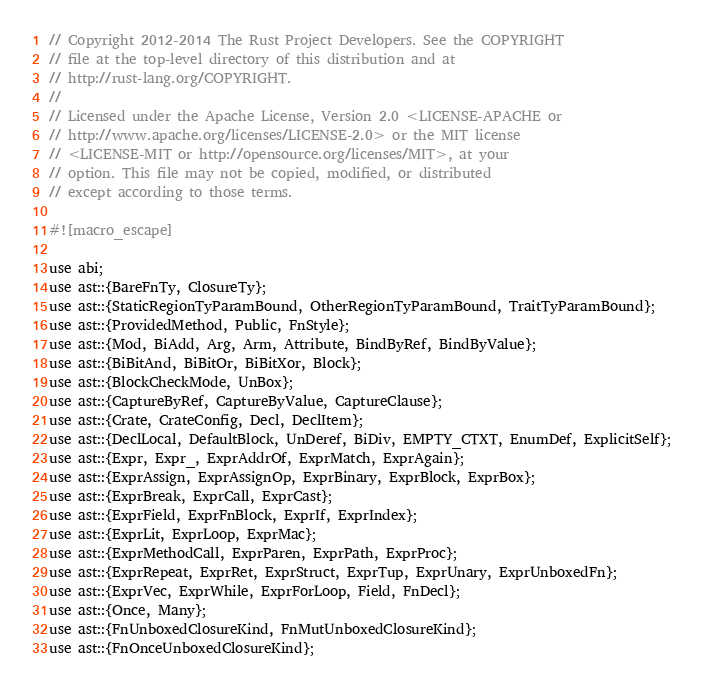<code> <loc_0><loc_0><loc_500><loc_500><_Rust_>// Copyright 2012-2014 The Rust Project Developers. See the COPYRIGHT
// file at the top-level directory of this distribution and at
// http://rust-lang.org/COPYRIGHT.
//
// Licensed under the Apache License, Version 2.0 <LICENSE-APACHE or
// http://www.apache.org/licenses/LICENSE-2.0> or the MIT license
// <LICENSE-MIT or http://opensource.org/licenses/MIT>, at your
// option. This file may not be copied, modified, or distributed
// except according to those terms.

#![macro_escape]

use abi;
use ast::{BareFnTy, ClosureTy};
use ast::{StaticRegionTyParamBound, OtherRegionTyParamBound, TraitTyParamBound};
use ast::{ProvidedMethod, Public, FnStyle};
use ast::{Mod, BiAdd, Arg, Arm, Attribute, BindByRef, BindByValue};
use ast::{BiBitAnd, BiBitOr, BiBitXor, Block};
use ast::{BlockCheckMode, UnBox};
use ast::{CaptureByRef, CaptureByValue, CaptureClause};
use ast::{Crate, CrateConfig, Decl, DeclItem};
use ast::{DeclLocal, DefaultBlock, UnDeref, BiDiv, EMPTY_CTXT, EnumDef, ExplicitSelf};
use ast::{Expr, Expr_, ExprAddrOf, ExprMatch, ExprAgain};
use ast::{ExprAssign, ExprAssignOp, ExprBinary, ExprBlock, ExprBox};
use ast::{ExprBreak, ExprCall, ExprCast};
use ast::{ExprField, ExprFnBlock, ExprIf, ExprIndex};
use ast::{ExprLit, ExprLoop, ExprMac};
use ast::{ExprMethodCall, ExprParen, ExprPath, ExprProc};
use ast::{ExprRepeat, ExprRet, ExprStruct, ExprTup, ExprUnary, ExprUnboxedFn};
use ast::{ExprVec, ExprWhile, ExprForLoop, Field, FnDecl};
use ast::{Once, Many};
use ast::{FnUnboxedClosureKind, FnMutUnboxedClosureKind};
use ast::{FnOnceUnboxedClosureKind};</code> 